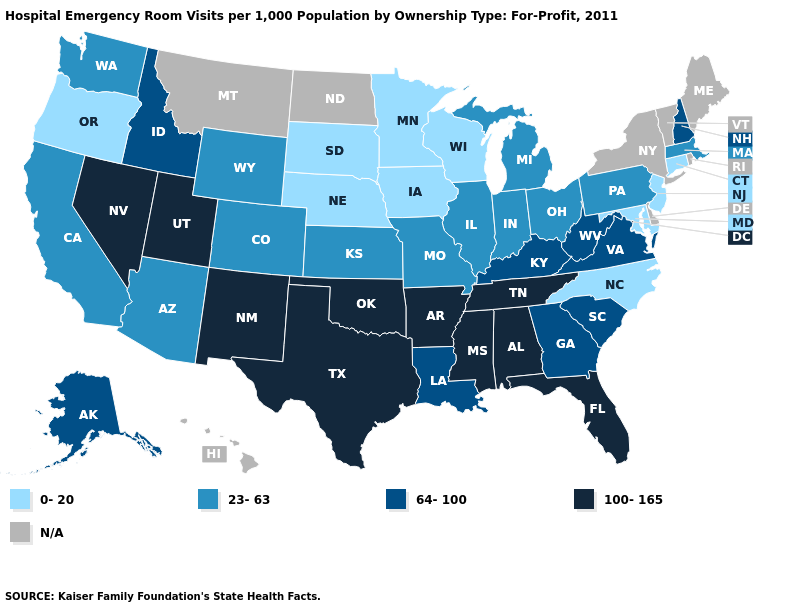What is the highest value in states that border Wyoming?
Short answer required. 100-165. Name the states that have a value in the range N/A?
Answer briefly. Delaware, Hawaii, Maine, Montana, New York, North Dakota, Rhode Island, Vermont. Does the first symbol in the legend represent the smallest category?
Quick response, please. Yes. Name the states that have a value in the range 100-165?
Short answer required. Alabama, Arkansas, Florida, Mississippi, Nevada, New Mexico, Oklahoma, Tennessee, Texas, Utah. What is the value of Maine?
Answer briefly. N/A. Does the first symbol in the legend represent the smallest category?
Keep it brief. Yes. How many symbols are there in the legend?
Short answer required. 5. Among the states that border Ohio , does Kentucky have the lowest value?
Short answer required. No. What is the highest value in states that border Kansas?
Quick response, please. 100-165. Which states hav the highest value in the MidWest?
Give a very brief answer. Illinois, Indiana, Kansas, Michigan, Missouri, Ohio. Which states have the highest value in the USA?
Answer briefly. Alabama, Arkansas, Florida, Mississippi, Nevada, New Mexico, Oklahoma, Tennessee, Texas, Utah. What is the lowest value in the USA?
Give a very brief answer. 0-20. Is the legend a continuous bar?
Be succinct. No. 